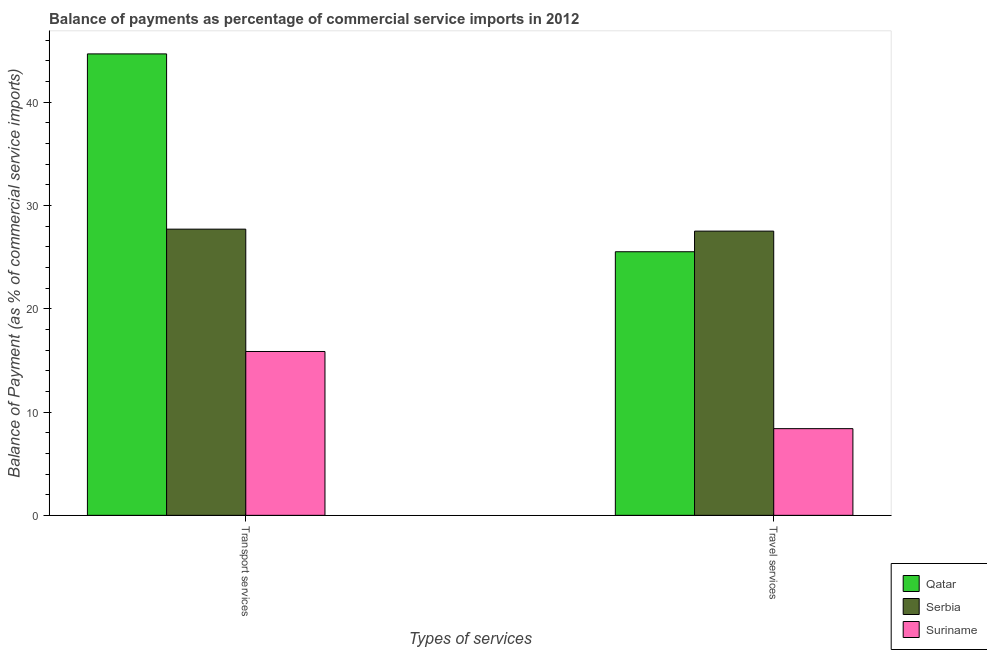Are the number of bars per tick equal to the number of legend labels?
Your response must be concise. Yes. How many bars are there on the 2nd tick from the left?
Give a very brief answer. 3. What is the label of the 1st group of bars from the left?
Give a very brief answer. Transport services. What is the balance of payments of travel services in Qatar?
Keep it short and to the point. 25.53. Across all countries, what is the maximum balance of payments of travel services?
Offer a very short reply. 27.53. Across all countries, what is the minimum balance of payments of transport services?
Your answer should be very brief. 15.87. In which country was the balance of payments of travel services maximum?
Make the answer very short. Serbia. In which country was the balance of payments of transport services minimum?
Your answer should be compact. Suriname. What is the total balance of payments of travel services in the graph?
Give a very brief answer. 61.45. What is the difference between the balance of payments of transport services in Qatar and that in Suriname?
Provide a short and direct response. 28.82. What is the difference between the balance of payments of transport services in Serbia and the balance of payments of travel services in Qatar?
Make the answer very short. 2.19. What is the average balance of payments of travel services per country?
Give a very brief answer. 20.48. What is the difference between the balance of payments of transport services and balance of payments of travel services in Serbia?
Provide a short and direct response. 0.19. In how many countries, is the balance of payments of travel services greater than 24 %?
Offer a terse response. 2. What is the ratio of the balance of payments of transport services in Suriname to that in Qatar?
Keep it short and to the point. 0.36. Is the balance of payments of transport services in Serbia less than that in Qatar?
Give a very brief answer. Yes. What does the 3rd bar from the left in Transport services represents?
Your response must be concise. Suriname. What does the 3rd bar from the right in Transport services represents?
Provide a succinct answer. Qatar. How many bars are there?
Your answer should be very brief. 6. How many countries are there in the graph?
Ensure brevity in your answer.  3. Are the values on the major ticks of Y-axis written in scientific E-notation?
Your response must be concise. No. How many legend labels are there?
Keep it short and to the point. 3. How are the legend labels stacked?
Make the answer very short. Vertical. What is the title of the graph?
Your response must be concise. Balance of payments as percentage of commercial service imports in 2012. What is the label or title of the X-axis?
Your response must be concise. Types of services. What is the label or title of the Y-axis?
Offer a very short reply. Balance of Payment (as % of commercial service imports). What is the Balance of Payment (as % of commercial service imports) of Qatar in Transport services?
Provide a succinct answer. 44.69. What is the Balance of Payment (as % of commercial service imports) of Serbia in Transport services?
Provide a short and direct response. 27.72. What is the Balance of Payment (as % of commercial service imports) of Suriname in Transport services?
Give a very brief answer. 15.87. What is the Balance of Payment (as % of commercial service imports) in Qatar in Travel services?
Your response must be concise. 25.53. What is the Balance of Payment (as % of commercial service imports) in Serbia in Travel services?
Your response must be concise. 27.53. What is the Balance of Payment (as % of commercial service imports) in Suriname in Travel services?
Ensure brevity in your answer.  8.4. Across all Types of services, what is the maximum Balance of Payment (as % of commercial service imports) in Qatar?
Provide a succinct answer. 44.69. Across all Types of services, what is the maximum Balance of Payment (as % of commercial service imports) in Serbia?
Ensure brevity in your answer.  27.72. Across all Types of services, what is the maximum Balance of Payment (as % of commercial service imports) of Suriname?
Give a very brief answer. 15.87. Across all Types of services, what is the minimum Balance of Payment (as % of commercial service imports) of Qatar?
Ensure brevity in your answer.  25.53. Across all Types of services, what is the minimum Balance of Payment (as % of commercial service imports) of Serbia?
Give a very brief answer. 27.53. Across all Types of services, what is the minimum Balance of Payment (as % of commercial service imports) of Suriname?
Give a very brief answer. 8.4. What is the total Balance of Payment (as % of commercial service imports) of Qatar in the graph?
Ensure brevity in your answer.  70.21. What is the total Balance of Payment (as % of commercial service imports) in Serbia in the graph?
Provide a succinct answer. 55.24. What is the total Balance of Payment (as % of commercial service imports) in Suriname in the graph?
Make the answer very short. 24.26. What is the difference between the Balance of Payment (as % of commercial service imports) in Qatar in Transport services and that in Travel services?
Your answer should be compact. 19.16. What is the difference between the Balance of Payment (as % of commercial service imports) in Serbia in Transport services and that in Travel services?
Make the answer very short. 0.19. What is the difference between the Balance of Payment (as % of commercial service imports) of Suriname in Transport services and that in Travel services?
Offer a very short reply. 7.47. What is the difference between the Balance of Payment (as % of commercial service imports) of Qatar in Transport services and the Balance of Payment (as % of commercial service imports) of Serbia in Travel services?
Your answer should be very brief. 17.16. What is the difference between the Balance of Payment (as % of commercial service imports) in Qatar in Transport services and the Balance of Payment (as % of commercial service imports) in Suriname in Travel services?
Offer a very short reply. 36.29. What is the difference between the Balance of Payment (as % of commercial service imports) of Serbia in Transport services and the Balance of Payment (as % of commercial service imports) of Suriname in Travel services?
Ensure brevity in your answer.  19.32. What is the average Balance of Payment (as % of commercial service imports) of Qatar per Types of services?
Keep it short and to the point. 35.11. What is the average Balance of Payment (as % of commercial service imports) in Serbia per Types of services?
Give a very brief answer. 27.62. What is the average Balance of Payment (as % of commercial service imports) in Suriname per Types of services?
Provide a succinct answer. 12.13. What is the difference between the Balance of Payment (as % of commercial service imports) of Qatar and Balance of Payment (as % of commercial service imports) of Serbia in Transport services?
Offer a terse response. 16.97. What is the difference between the Balance of Payment (as % of commercial service imports) in Qatar and Balance of Payment (as % of commercial service imports) in Suriname in Transport services?
Make the answer very short. 28.82. What is the difference between the Balance of Payment (as % of commercial service imports) of Serbia and Balance of Payment (as % of commercial service imports) of Suriname in Transport services?
Offer a very short reply. 11.85. What is the difference between the Balance of Payment (as % of commercial service imports) of Qatar and Balance of Payment (as % of commercial service imports) of Serbia in Travel services?
Make the answer very short. -2. What is the difference between the Balance of Payment (as % of commercial service imports) in Qatar and Balance of Payment (as % of commercial service imports) in Suriname in Travel services?
Offer a terse response. 17.13. What is the difference between the Balance of Payment (as % of commercial service imports) of Serbia and Balance of Payment (as % of commercial service imports) of Suriname in Travel services?
Give a very brief answer. 19.13. What is the ratio of the Balance of Payment (as % of commercial service imports) of Qatar in Transport services to that in Travel services?
Your response must be concise. 1.75. What is the ratio of the Balance of Payment (as % of commercial service imports) in Suriname in Transport services to that in Travel services?
Your answer should be compact. 1.89. What is the difference between the highest and the second highest Balance of Payment (as % of commercial service imports) of Qatar?
Your answer should be compact. 19.16. What is the difference between the highest and the second highest Balance of Payment (as % of commercial service imports) of Serbia?
Offer a very short reply. 0.19. What is the difference between the highest and the second highest Balance of Payment (as % of commercial service imports) of Suriname?
Your response must be concise. 7.47. What is the difference between the highest and the lowest Balance of Payment (as % of commercial service imports) of Qatar?
Keep it short and to the point. 19.16. What is the difference between the highest and the lowest Balance of Payment (as % of commercial service imports) of Serbia?
Keep it short and to the point. 0.19. What is the difference between the highest and the lowest Balance of Payment (as % of commercial service imports) of Suriname?
Offer a terse response. 7.47. 